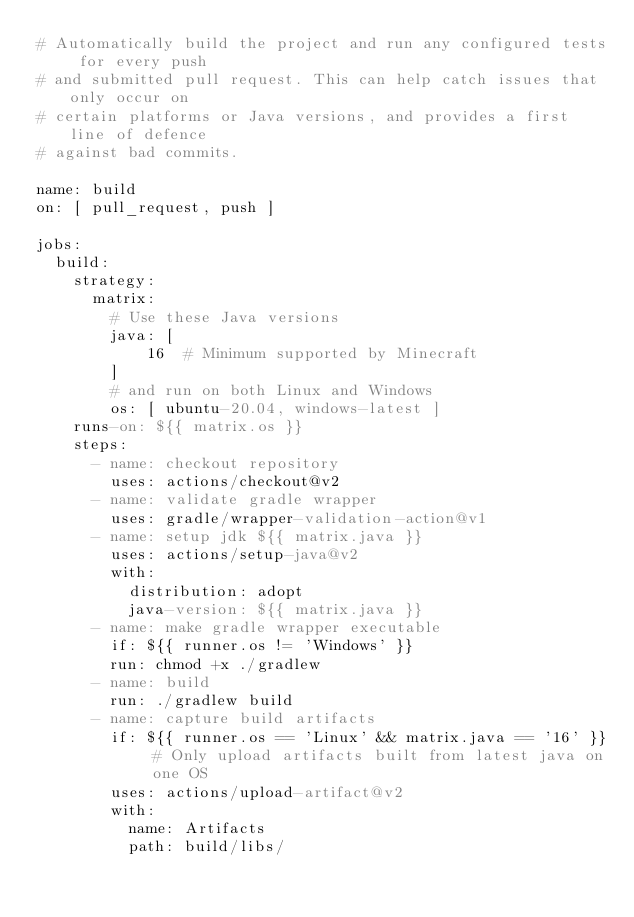Convert code to text. <code><loc_0><loc_0><loc_500><loc_500><_YAML_># Automatically build the project and run any configured tests for every push
# and submitted pull request. This can help catch issues that only occur on
# certain platforms or Java versions, and provides a first line of defence
# against bad commits.

name: build
on: [ pull_request, push ]

jobs:
  build:
    strategy:
      matrix:
        # Use these Java versions
        java: [
            16  # Minimum supported by Minecraft
        ]
        # and run on both Linux and Windows
        os: [ ubuntu-20.04, windows-latest ]
    runs-on: ${{ matrix.os }}
    steps:
      - name: checkout repository
        uses: actions/checkout@v2
      - name: validate gradle wrapper
        uses: gradle/wrapper-validation-action@v1
      - name: setup jdk ${{ matrix.java }}
        uses: actions/setup-java@v2
        with:
          distribution: adopt
          java-version: ${{ matrix.java }}
      - name: make gradle wrapper executable
        if: ${{ runner.os != 'Windows' }}
        run: chmod +x ./gradlew
      - name: build
        run: ./gradlew build
      - name: capture build artifacts
        if: ${{ runner.os == 'Linux' && matrix.java == '16' }} # Only upload artifacts built from latest java on one OS
        uses: actions/upload-artifact@v2
        with:
          name: Artifacts
          path: build/libs/
</code> 